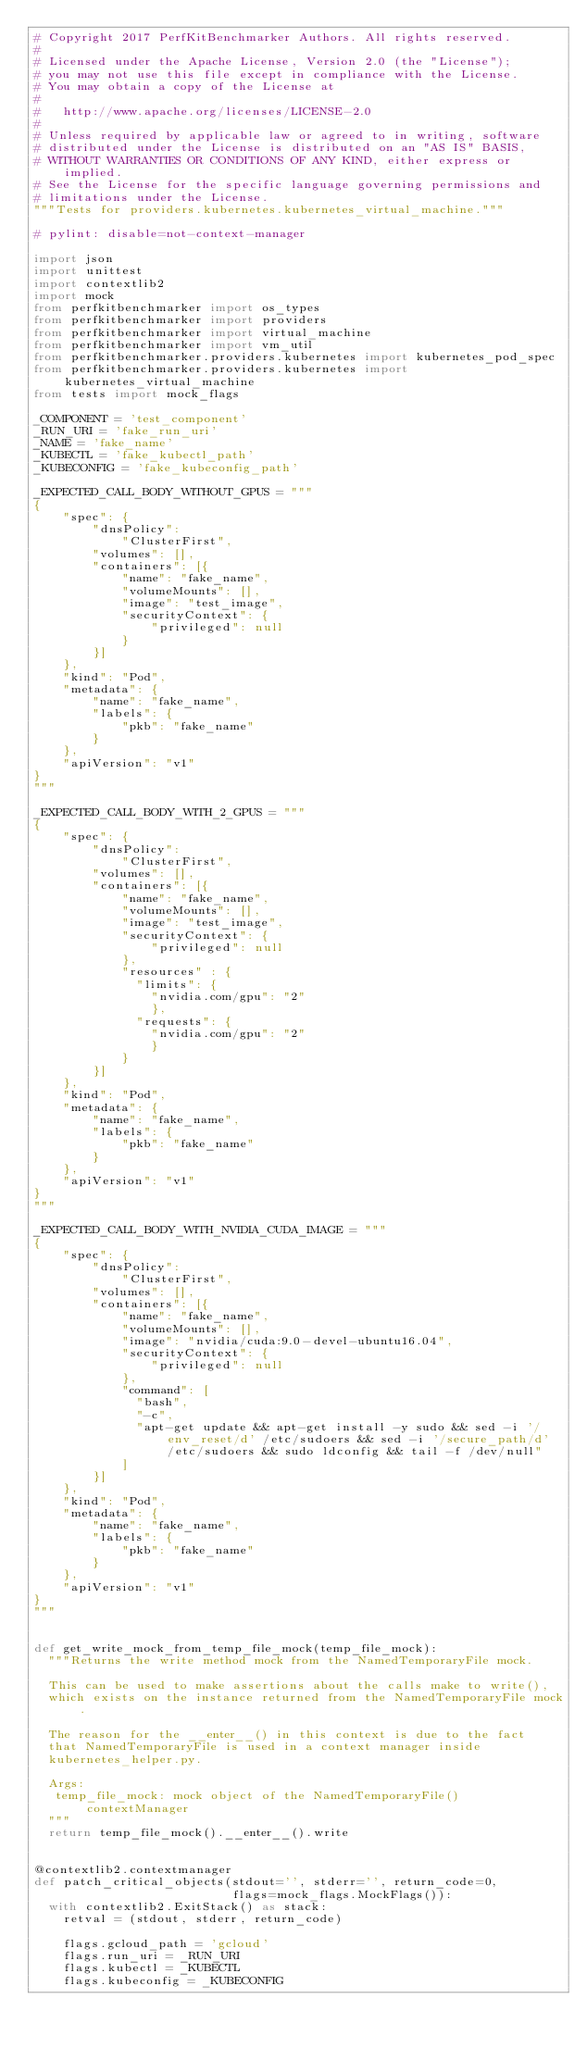Convert code to text. <code><loc_0><loc_0><loc_500><loc_500><_Python_># Copyright 2017 PerfKitBenchmarker Authors. All rights reserved.
#
# Licensed under the Apache License, Version 2.0 (the "License");
# you may not use this file except in compliance with the License.
# You may obtain a copy of the License at
#
#   http://www.apache.org/licenses/LICENSE-2.0
#
# Unless required by applicable law or agreed to in writing, software
# distributed under the License is distributed on an "AS IS" BASIS,
# WITHOUT WARRANTIES OR CONDITIONS OF ANY KIND, either express or implied.
# See the License for the specific language governing permissions and
# limitations under the License.
"""Tests for providers.kubernetes.kubernetes_virtual_machine."""

# pylint: disable=not-context-manager

import json
import unittest
import contextlib2
import mock
from perfkitbenchmarker import os_types
from perfkitbenchmarker import providers
from perfkitbenchmarker import virtual_machine
from perfkitbenchmarker import vm_util
from perfkitbenchmarker.providers.kubernetes import kubernetes_pod_spec
from perfkitbenchmarker.providers.kubernetes import kubernetes_virtual_machine
from tests import mock_flags

_COMPONENT = 'test_component'
_RUN_URI = 'fake_run_uri'
_NAME = 'fake_name'
_KUBECTL = 'fake_kubectl_path'
_KUBECONFIG = 'fake_kubeconfig_path'

_EXPECTED_CALL_BODY_WITHOUT_GPUS = """
{
    "spec": {
        "dnsPolicy":
            "ClusterFirst",
        "volumes": [],
        "containers": [{
            "name": "fake_name",
            "volumeMounts": [],
            "image": "test_image",
            "securityContext": {
                "privileged": null
            }
        }]
    },
    "kind": "Pod",
    "metadata": {
        "name": "fake_name",
        "labels": {
            "pkb": "fake_name"
        }
    },
    "apiVersion": "v1"
}
"""

_EXPECTED_CALL_BODY_WITH_2_GPUS = """
{
    "spec": {
        "dnsPolicy":
            "ClusterFirst",
        "volumes": [],
        "containers": [{
            "name": "fake_name",
            "volumeMounts": [],
            "image": "test_image",
            "securityContext": {
                "privileged": null
            },
            "resources" : {
              "limits": {
                "nvidia.com/gpu": "2"
                },
              "requests": {
                "nvidia.com/gpu": "2"
                }
            }
        }]
    },
    "kind": "Pod",
    "metadata": {
        "name": "fake_name",
        "labels": {
            "pkb": "fake_name"
        }
    },
    "apiVersion": "v1"
}
"""

_EXPECTED_CALL_BODY_WITH_NVIDIA_CUDA_IMAGE = """
{
    "spec": {
        "dnsPolicy":
            "ClusterFirst",
        "volumes": [],
        "containers": [{
            "name": "fake_name",
            "volumeMounts": [],
            "image": "nvidia/cuda:9.0-devel-ubuntu16.04",
            "securityContext": {
                "privileged": null
            },
            "command": [
              "bash",
              "-c",
              "apt-get update && apt-get install -y sudo && sed -i '/env_reset/d' /etc/sudoers && sed -i '/secure_path/d' /etc/sudoers && sudo ldconfig && tail -f /dev/null"
            ]
        }]
    },
    "kind": "Pod",
    "metadata": {
        "name": "fake_name",
        "labels": {
            "pkb": "fake_name"
        }
    },
    "apiVersion": "v1"
}
"""


def get_write_mock_from_temp_file_mock(temp_file_mock):
  """Returns the write method mock from the NamedTemporaryFile mock.

  This can be used to make assertions about the calls make to write(),
  which exists on the instance returned from the NamedTemporaryFile mock.

  The reason for the __enter__() in this context is due to the fact
  that NamedTemporaryFile is used in a context manager inside
  kubernetes_helper.py.

  Args:
   temp_file_mock: mock object of the NamedTemporaryFile() contextManager
  """
  return temp_file_mock().__enter__().write


@contextlib2.contextmanager
def patch_critical_objects(stdout='', stderr='', return_code=0,
                           flags=mock_flags.MockFlags()):
  with contextlib2.ExitStack() as stack:
    retval = (stdout, stderr, return_code)

    flags.gcloud_path = 'gcloud'
    flags.run_uri = _RUN_URI
    flags.kubectl = _KUBECTL
    flags.kubeconfig = _KUBECONFIG
</code> 